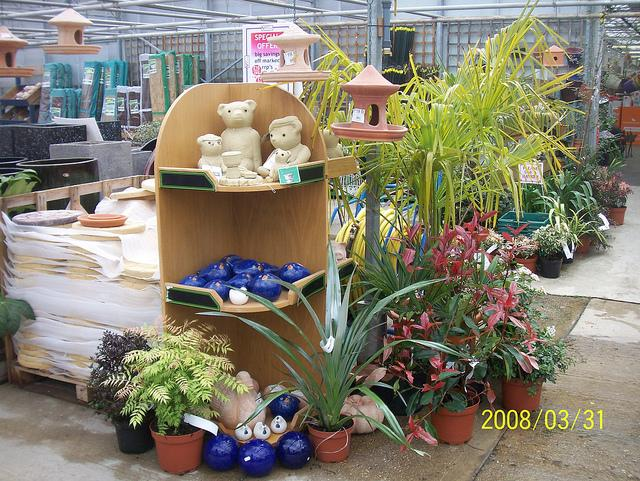What kind of animal is on the top shelf? Please explain your reasoning. bear. Bears are on the top shelf. 